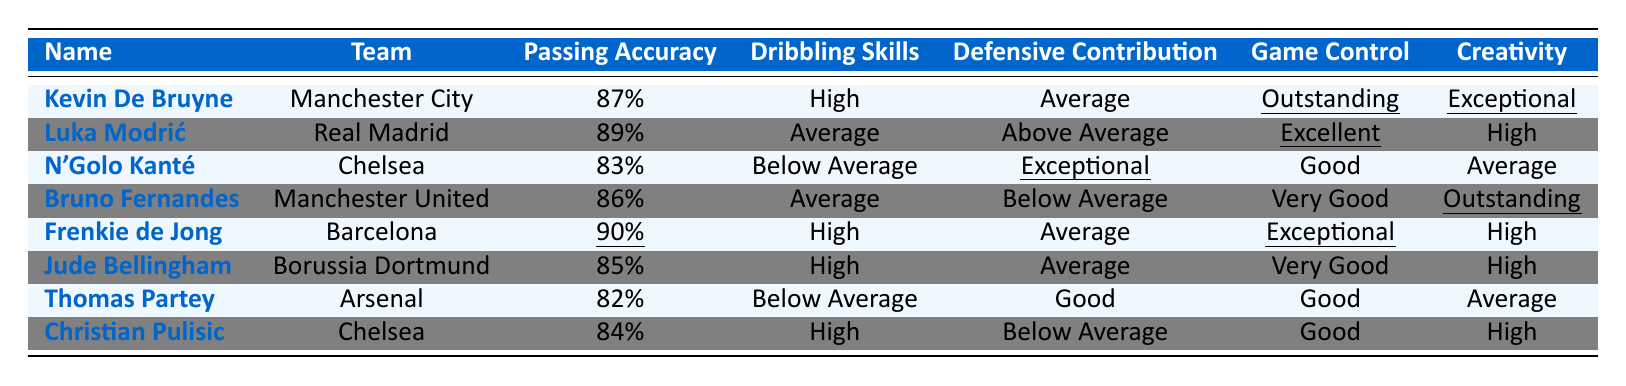What is the highest passing accuracy among the midfielders? By examining the "Passing Accuracy" column, the midfielder with the highest percentage is Frenkie de Jong at 90%.
Answer: 90% Who has the best game control according to the table? The "Game Control" column shows that Kevin De Bruyne has "Outstanding" control, which is the highest rating.
Answer: Kevin De Bruyne Which midfielder has the lowest defensive contribution? Looking at the "Defensive Contribution" column, N'Golo Kanté and Bruno Fernandes have "Below Average," which is the lowest rating.
Answer: N'Golo Kanté and Bruno Fernandes Is Luka Modrić's dribbling skill above average? The "Dribbling Skills" column indicates that Luka Modrić is rated as "Average," which is not above average.
Answer: No How many midfielders have high dribbling skills? By counting the "High" ratings in the "Dribbling Skills" column, we find that there are four midfielders: Kevin De Bruyne, Frenkie de Jong, Jude Bellingham, and Christian Pulisic.
Answer: 4 Which midfielder has the best creativity while also having average defensive contribution? From the "Creativity" and "Defensive Contribution" columns, Jude Bellingham is rated "High" for creativity and "Average" for defensive contribution, making him the best in this category.
Answer: Jude Bellingham What is the difference in passing accuracy between the highest and lowest-rated midfielders? The highest passing accuracy is 90% (Frenkie de Jong) and the lowest is 82% (Thomas Partey). The difference is 90% - 82% = 8%.
Answer: 8% Is there any midfielder with exceptional defensive contribution? The defensive contributions indicate N'Golo Kanté has "Exceptional," confirming that there is at least one midfielder with this rating.
Answer: Yes Which midfielder's team is Chelsea? The table shows that two midfielders play for Chelsea: N'Golo Kanté and Christian Pulisic.
Answer: N'Golo Kanté and Christian Pulisic Who has the highest passing accuracy and hobby dribbling skills? Frenkie de Jong has the highest passing accuracy (90%) and also possesses high dribbling skills.
Answer: Frenkie de Jong 